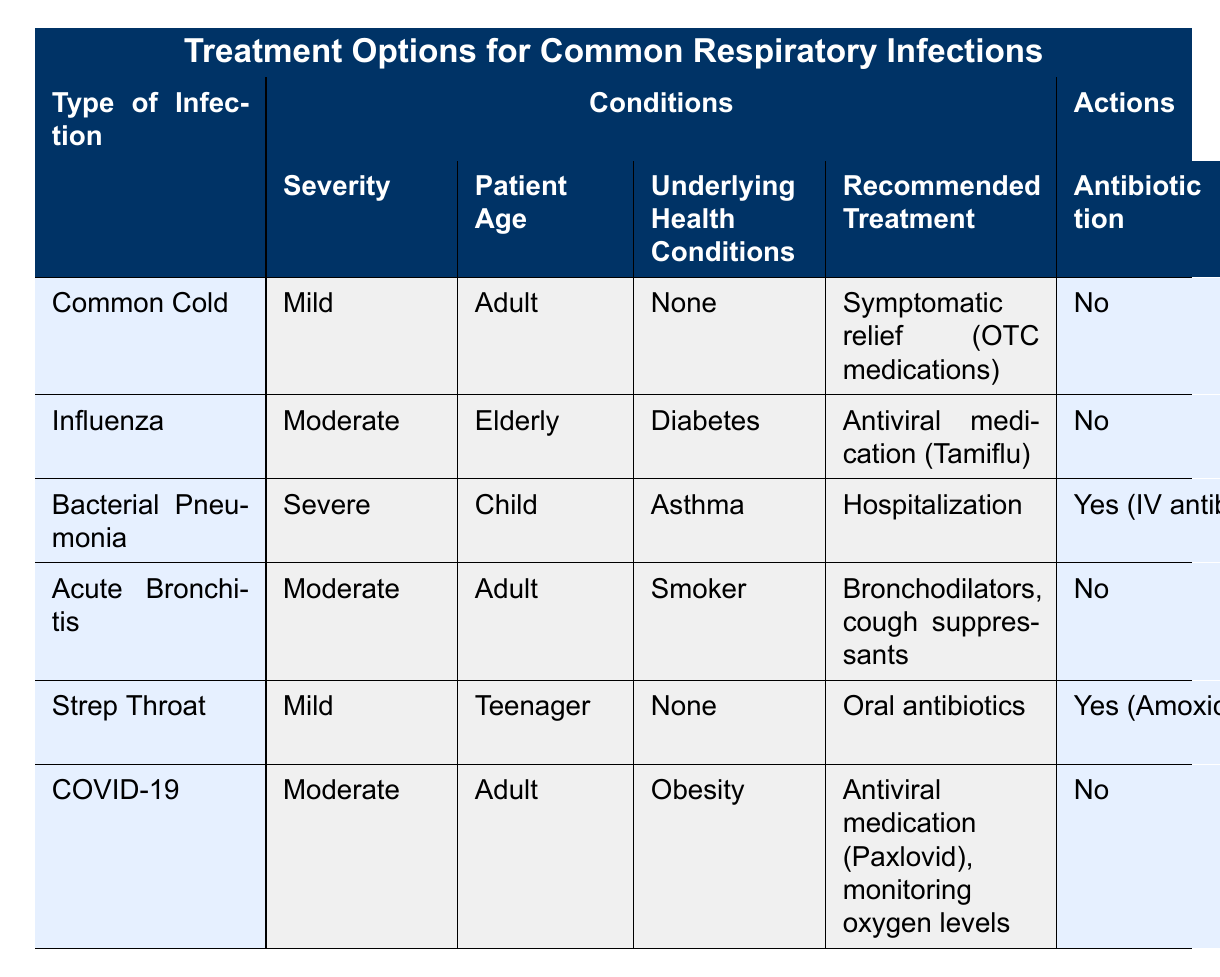What is the recommended treatment for a common cold in an adult with no underlying health conditions? The table indicates that for a common cold with mild severity in an adult with no underlying health conditions, the recommended treatment is "Symptomatic relief (OTC medications)."
Answer: Symptomatic relief (OTC medications) Is an antibiotic prescribed for strep throat in a teenager? According to the table, strep throat is treated with oral antibiotics (specifically Amoxicillin) and the antibiotic prescription is marked "Yes."
Answer: Yes How many days of rest are recommended for a child with severe bacterial pneumonia? The table states that for severe bacterial pneumonia in a child with asthma, the recommended rest duration is 14 days.
Answer: 14 days If an adult is diagnosed with moderate influenza and has diabetes, what follow-up appointment is recommended? The table shows that for moderate influenza in an elderly patient with diabetes, a follow-up appointment is advised after 5 days.
Answer: Yes, after 5 days What is the difference in recommended rest duration between COVID-19 and acute bronchitis in adults? For COVID-19, the recommended rest duration is 10 days, and for acute bronchitis, it is 5 days. Therefore, the difference in rest duration is 10 - 5 = 5 days.
Answer: 5 days For a patient with obesity suffering from moderate COVID-19, is an antibiotic prescribed? The table specifies that for COVID-19, the antibiotic prescription is marked "No." Therefore, no antibiotic is prescribed for such a patient.
Answer: No What treatments are recommended for an adult who is a smoker and has moderate acute bronchitis? The table indicates that for a moderate case of acute bronchitis in an adult who is a smoker, the recommended treatments are bronchodilators and cough suppressants.
Answer: Bronchodilators, cough suppressants Are follow-up appointments necessary for patients with mild conditions like a common cold or strep throat? The table indicates that for a common cold, a follow-up appointment is only needed if symptoms worsen. For strep throat, it is also only if symptoms persist. Therefore, follow-up appointments are not routinely necessary for these mild conditions.
Answer: No What is the total number of days recommended for rest in cases of bacterial pneumonia compared to influenza? The recommended rest duration for bacterial pneumonia is 14 days, while for influenza, it is 7 days. The total is 14 + 7 = 21 days.
Answer: 21 days 